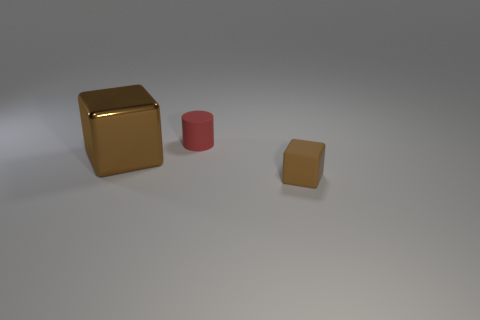Add 1 cylinders. How many objects exist? 4 Subtract all cylinders. How many objects are left? 2 Add 3 big shiny things. How many big shiny things exist? 4 Subtract 0 brown cylinders. How many objects are left? 3 Subtract all big yellow blocks. Subtract all cubes. How many objects are left? 1 Add 3 brown objects. How many brown objects are left? 5 